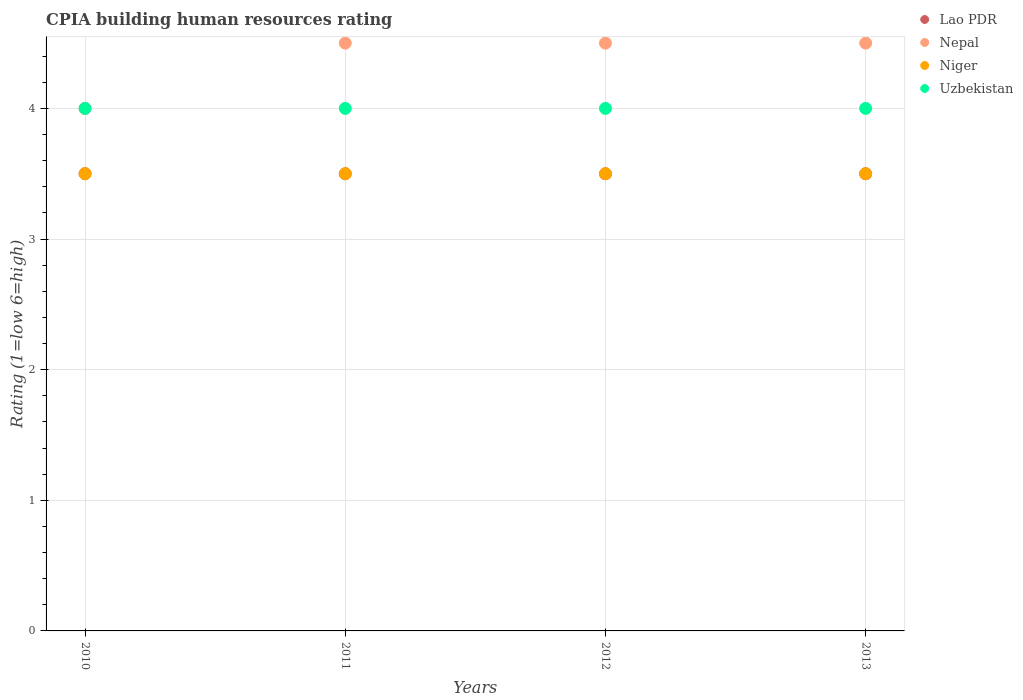What is the CPIA rating in Uzbekistan in 2013?
Your answer should be compact. 4. Across all years, what is the maximum CPIA rating in Uzbekistan?
Your answer should be compact. 4. Across all years, what is the minimum CPIA rating in Nepal?
Offer a very short reply. 4. In which year was the CPIA rating in Nepal maximum?
Your answer should be compact. 2011. In which year was the CPIA rating in Lao PDR minimum?
Provide a short and direct response. 2010. What is the total CPIA rating in Nepal in the graph?
Ensure brevity in your answer.  17.5. What is the difference between the CPIA rating in Uzbekistan in 2011 and the CPIA rating in Lao PDR in 2010?
Your response must be concise. 0.5. What is the average CPIA rating in Lao PDR per year?
Provide a short and direct response. 3.5. What is the ratio of the CPIA rating in Nepal in 2010 to that in 2012?
Your response must be concise. 0.89. Is the CPIA rating in Niger in 2012 less than that in 2013?
Your response must be concise. No. What is the difference between the highest and the second highest CPIA rating in Lao PDR?
Offer a very short reply. 0. What is the difference between the highest and the lowest CPIA rating in Uzbekistan?
Your response must be concise. 0. In how many years, is the CPIA rating in Nepal greater than the average CPIA rating in Nepal taken over all years?
Your answer should be very brief. 3. Is the sum of the CPIA rating in Lao PDR in 2010 and 2011 greater than the maximum CPIA rating in Uzbekistan across all years?
Give a very brief answer. Yes. Is it the case that in every year, the sum of the CPIA rating in Lao PDR and CPIA rating in Nepal  is greater than the sum of CPIA rating in Niger and CPIA rating in Uzbekistan?
Your answer should be very brief. No. Does the CPIA rating in Niger monotonically increase over the years?
Your answer should be very brief. No. Is the CPIA rating in Nepal strictly less than the CPIA rating in Uzbekistan over the years?
Make the answer very short. No. How many dotlines are there?
Your response must be concise. 4. Are the values on the major ticks of Y-axis written in scientific E-notation?
Offer a very short reply. No. How are the legend labels stacked?
Provide a short and direct response. Vertical. What is the title of the graph?
Offer a very short reply. CPIA building human resources rating. What is the label or title of the X-axis?
Make the answer very short. Years. What is the label or title of the Y-axis?
Make the answer very short. Rating (1=low 6=high). What is the Rating (1=low 6=high) of Lao PDR in 2010?
Provide a short and direct response. 3.5. What is the Rating (1=low 6=high) in Niger in 2010?
Provide a short and direct response. 3.5. What is the Rating (1=low 6=high) in Uzbekistan in 2010?
Give a very brief answer. 4. What is the Rating (1=low 6=high) in Lao PDR in 2011?
Your answer should be compact. 3.5. What is the Rating (1=low 6=high) in Nepal in 2011?
Ensure brevity in your answer.  4.5. What is the Rating (1=low 6=high) of Nepal in 2012?
Your answer should be compact. 4.5. What is the Rating (1=low 6=high) of Uzbekistan in 2012?
Make the answer very short. 4. What is the Rating (1=low 6=high) in Nepal in 2013?
Make the answer very short. 4.5. Across all years, what is the maximum Rating (1=low 6=high) of Niger?
Keep it short and to the point. 3.5. Across all years, what is the minimum Rating (1=low 6=high) in Nepal?
Make the answer very short. 4. Across all years, what is the minimum Rating (1=low 6=high) of Uzbekistan?
Your response must be concise. 4. What is the total Rating (1=low 6=high) in Lao PDR in the graph?
Make the answer very short. 14. What is the total Rating (1=low 6=high) of Nepal in the graph?
Offer a very short reply. 17.5. What is the total Rating (1=low 6=high) of Uzbekistan in the graph?
Give a very brief answer. 16. What is the difference between the Rating (1=low 6=high) of Nepal in 2010 and that in 2011?
Your answer should be very brief. -0.5. What is the difference between the Rating (1=low 6=high) of Niger in 2010 and that in 2011?
Your response must be concise. 0. What is the difference between the Rating (1=low 6=high) in Uzbekistan in 2010 and that in 2011?
Make the answer very short. 0. What is the difference between the Rating (1=low 6=high) in Lao PDR in 2010 and that in 2012?
Keep it short and to the point. 0. What is the difference between the Rating (1=low 6=high) of Niger in 2010 and that in 2012?
Provide a succinct answer. 0. What is the difference between the Rating (1=low 6=high) in Nepal in 2011 and that in 2012?
Your response must be concise. 0. What is the difference between the Rating (1=low 6=high) of Niger in 2011 and that in 2012?
Your answer should be very brief. 0. What is the difference between the Rating (1=low 6=high) in Uzbekistan in 2011 and that in 2012?
Offer a terse response. 0. What is the difference between the Rating (1=low 6=high) in Nepal in 2011 and that in 2013?
Offer a very short reply. 0. What is the difference between the Rating (1=low 6=high) of Niger in 2011 and that in 2013?
Give a very brief answer. 0. What is the difference between the Rating (1=low 6=high) of Uzbekistan in 2011 and that in 2013?
Keep it short and to the point. 0. What is the difference between the Rating (1=low 6=high) of Niger in 2012 and that in 2013?
Give a very brief answer. 0. What is the difference between the Rating (1=low 6=high) in Nepal in 2010 and the Rating (1=low 6=high) in Uzbekistan in 2011?
Your response must be concise. 0. What is the difference between the Rating (1=low 6=high) of Niger in 2010 and the Rating (1=low 6=high) of Uzbekistan in 2011?
Offer a terse response. -0.5. What is the difference between the Rating (1=low 6=high) of Nepal in 2010 and the Rating (1=low 6=high) of Niger in 2012?
Provide a succinct answer. 0.5. What is the difference between the Rating (1=low 6=high) in Nepal in 2010 and the Rating (1=low 6=high) in Uzbekistan in 2012?
Ensure brevity in your answer.  0. What is the difference between the Rating (1=low 6=high) in Niger in 2010 and the Rating (1=low 6=high) in Uzbekistan in 2012?
Make the answer very short. -0.5. What is the difference between the Rating (1=low 6=high) in Nepal in 2010 and the Rating (1=low 6=high) in Niger in 2013?
Ensure brevity in your answer.  0.5. What is the difference between the Rating (1=low 6=high) of Lao PDR in 2011 and the Rating (1=low 6=high) of Nepal in 2012?
Your answer should be compact. -1. What is the difference between the Rating (1=low 6=high) of Nepal in 2011 and the Rating (1=low 6=high) of Niger in 2012?
Ensure brevity in your answer.  1. What is the difference between the Rating (1=low 6=high) in Niger in 2011 and the Rating (1=low 6=high) in Uzbekistan in 2012?
Provide a short and direct response. -0.5. What is the difference between the Rating (1=low 6=high) of Lao PDR in 2011 and the Rating (1=low 6=high) of Niger in 2013?
Ensure brevity in your answer.  0. What is the difference between the Rating (1=low 6=high) of Lao PDR in 2011 and the Rating (1=low 6=high) of Uzbekistan in 2013?
Keep it short and to the point. -0.5. What is the difference between the Rating (1=low 6=high) in Nepal in 2011 and the Rating (1=low 6=high) in Niger in 2013?
Keep it short and to the point. 1. What is the difference between the Rating (1=low 6=high) of Nepal in 2011 and the Rating (1=low 6=high) of Uzbekistan in 2013?
Ensure brevity in your answer.  0.5. What is the difference between the Rating (1=low 6=high) of Lao PDR in 2012 and the Rating (1=low 6=high) of Nepal in 2013?
Your answer should be compact. -1. What is the difference between the Rating (1=low 6=high) in Lao PDR in 2012 and the Rating (1=low 6=high) in Niger in 2013?
Offer a very short reply. 0. What is the difference between the Rating (1=low 6=high) of Nepal in 2012 and the Rating (1=low 6=high) of Niger in 2013?
Offer a terse response. 1. What is the difference between the Rating (1=low 6=high) of Nepal in 2012 and the Rating (1=low 6=high) of Uzbekistan in 2013?
Give a very brief answer. 0.5. What is the difference between the Rating (1=low 6=high) in Niger in 2012 and the Rating (1=low 6=high) in Uzbekistan in 2013?
Your answer should be compact. -0.5. What is the average Rating (1=low 6=high) in Lao PDR per year?
Provide a short and direct response. 3.5. What is the average Rating (1=low 6=high) in Nepal per year?
Your answer should be compact. 4.38. What is the average Rating (1=low 6=high) of Niger per year?
Offer a terse response. 3.5. What is the average Rating (1=low 6=high) of Uzbekistan per year?
Give a very brief answer. 4. In the year 2010, what is the difference between the Rating (1=low 6=high) in Lao PDR and Rating (1=low 6=high) in Uzbekistan?
Keep it short and to the point. -0.5. In the year 2010, what is the difference between the Rating (1=low 6=high) in Nepal and Rating (1=low 6=high) in Niger?
Your response must be concise. 0.5. In the year 2011, what is the difference between the Rating (1=low 6=high) of Lao PDR and Rating (1=low 6=high) of Niger?
Offer a very short reply. 0. In the year 2011, what is the difference between the Rating (1=low 6=high) of Niger and Rating (1=low 6=high) of Uzbekistan?
Your answer should be very brief. -0.5. In the year 2012, what is the difference between the Rating (1=low 6=high) in Lao PDR and Rating (1=low 6=high) in Uzbekistan?
Ensure brevity in your answer.  -0.5. In the year 2012, what is the difference between the Rating (1=low 6=high) of Nepal and Rating (1=low 6=high) of Niger?
Give a very brief answer. 1. In the year 2012, what is the difference between the Rating (1=low 6=high) in Nepal and Rating (1=low 6=high) in Uzbekistan?
Ensure brevity in your answer.  0.5. In the year 2012, what is the difference between the Rating (1=low 6=high) of Niger and Rating (1=low 6=high) of Uzbekistan?
Ensure brevity in your answer.  -0.5. In the year 2013, what is the difference between the Rating (1=low 6=high) in Nepal and Rating (1=low 6=high) in Niger?
Your response must be concise. 1. What is the ratio of the Rating (1=low 6=high) in Lao PDR in 2010 to that in 2011?
Offer a very short reply. 1. What is the ratio of the Rating (1=low 6=high) in Niger in 2010 to that in 2012?
Provide a succinct answer. 1. What is the ratio of the Rating (1=low 6=high) in Lao PDR in 2010 to that in 2013?
Make the answer very short. 1. What is the ratio of the Rating (1=low 6=high) in Niger in 2010 to that in 2013?
Offer a terse response. 1. What is the ratio of the Rating (1=low 6=high) in Nepal in 2011 to that in 2012?
Your answer should be compact. 1. What is the ratio of the Rating (1=low 6=high) in Niger in 2011 to that in 2012?
Ensure brevity in your answer.  1. What is the ratio of the Rating (1=low 6=high) of Uzbekistan in 2011 to that in 2012?
Ensure brevity in your answer.  1. What is the ratio of the Rating (1=low 6=high) in Lao PDR in 2011 to that in 2013?
Your response must be concise. 1. What is the ratio of the Rating (1=low 6=high) in Nepal in 2011 to that in 2013?
Your answer should be very brief. 1. What is the ratio of the Rating (1=low 6=high) of Niger in 2011 to that in 2013?
Provide a succinct answer. 1. What is the ratio of the Rating (1=low 6=high) in Uzbekistan in 2011 to that in 2013?
Offer a terse response. 1. What is the ratio of the Rating (1=low 6=high) of Nepal in 2012 to that in 2013?
Make the answer very short. 1. What is the ratio of the Rating (1=low 6=high) in Niger in 2012 to that in 2013?
Provide a succinct answer. 1. What is the difference between the highest and the lowest Rating (1=low 6=high) of Lao PDR?
Provide a succinct answer. 0. What is the difference between the highest and the lowest Rating (1=low 6=high) of Nepal?
Provide a short and direct response. 0.5. What is the difference between the highest and the lowest Rating (1=low 6=high) of Niger?
Ensure brevity in your answer.  0. What is the difference between the highest and the lowest Rating (1=low 6=high) in Uzbekistan?
Ensure brevity in your answer.  0. 